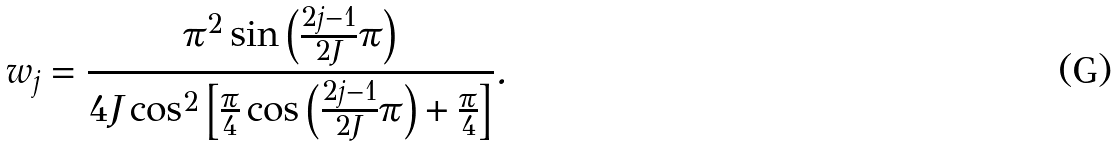<formula> <loc_0><loc_0><loc_500><loc_500>w _ { j } = \frac { \pi ^ { 2 } \sin \left ( \frac { 2 j - 1 } { 2 J } \pi \right ) } { 4 J \cos ^ { 2 } \left [ \frac { \pi } { 4 } \cos \left ( \frac { 2 j - 1 } { 2 J } \pi \right ) + \frac { \pi } { 4 } \right ] } .</formula> 